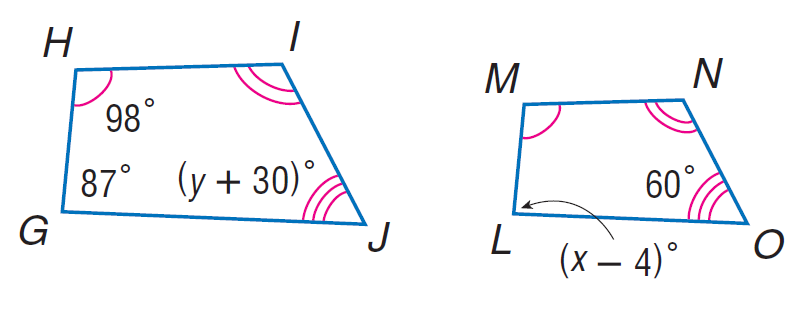Answer the mathemtical geometry problem and directly provide the correct option letter.
Question: Each pair of polygons is similar. Find y.
Choices: A: 30 B: 60 C: 87 D: 98 A 